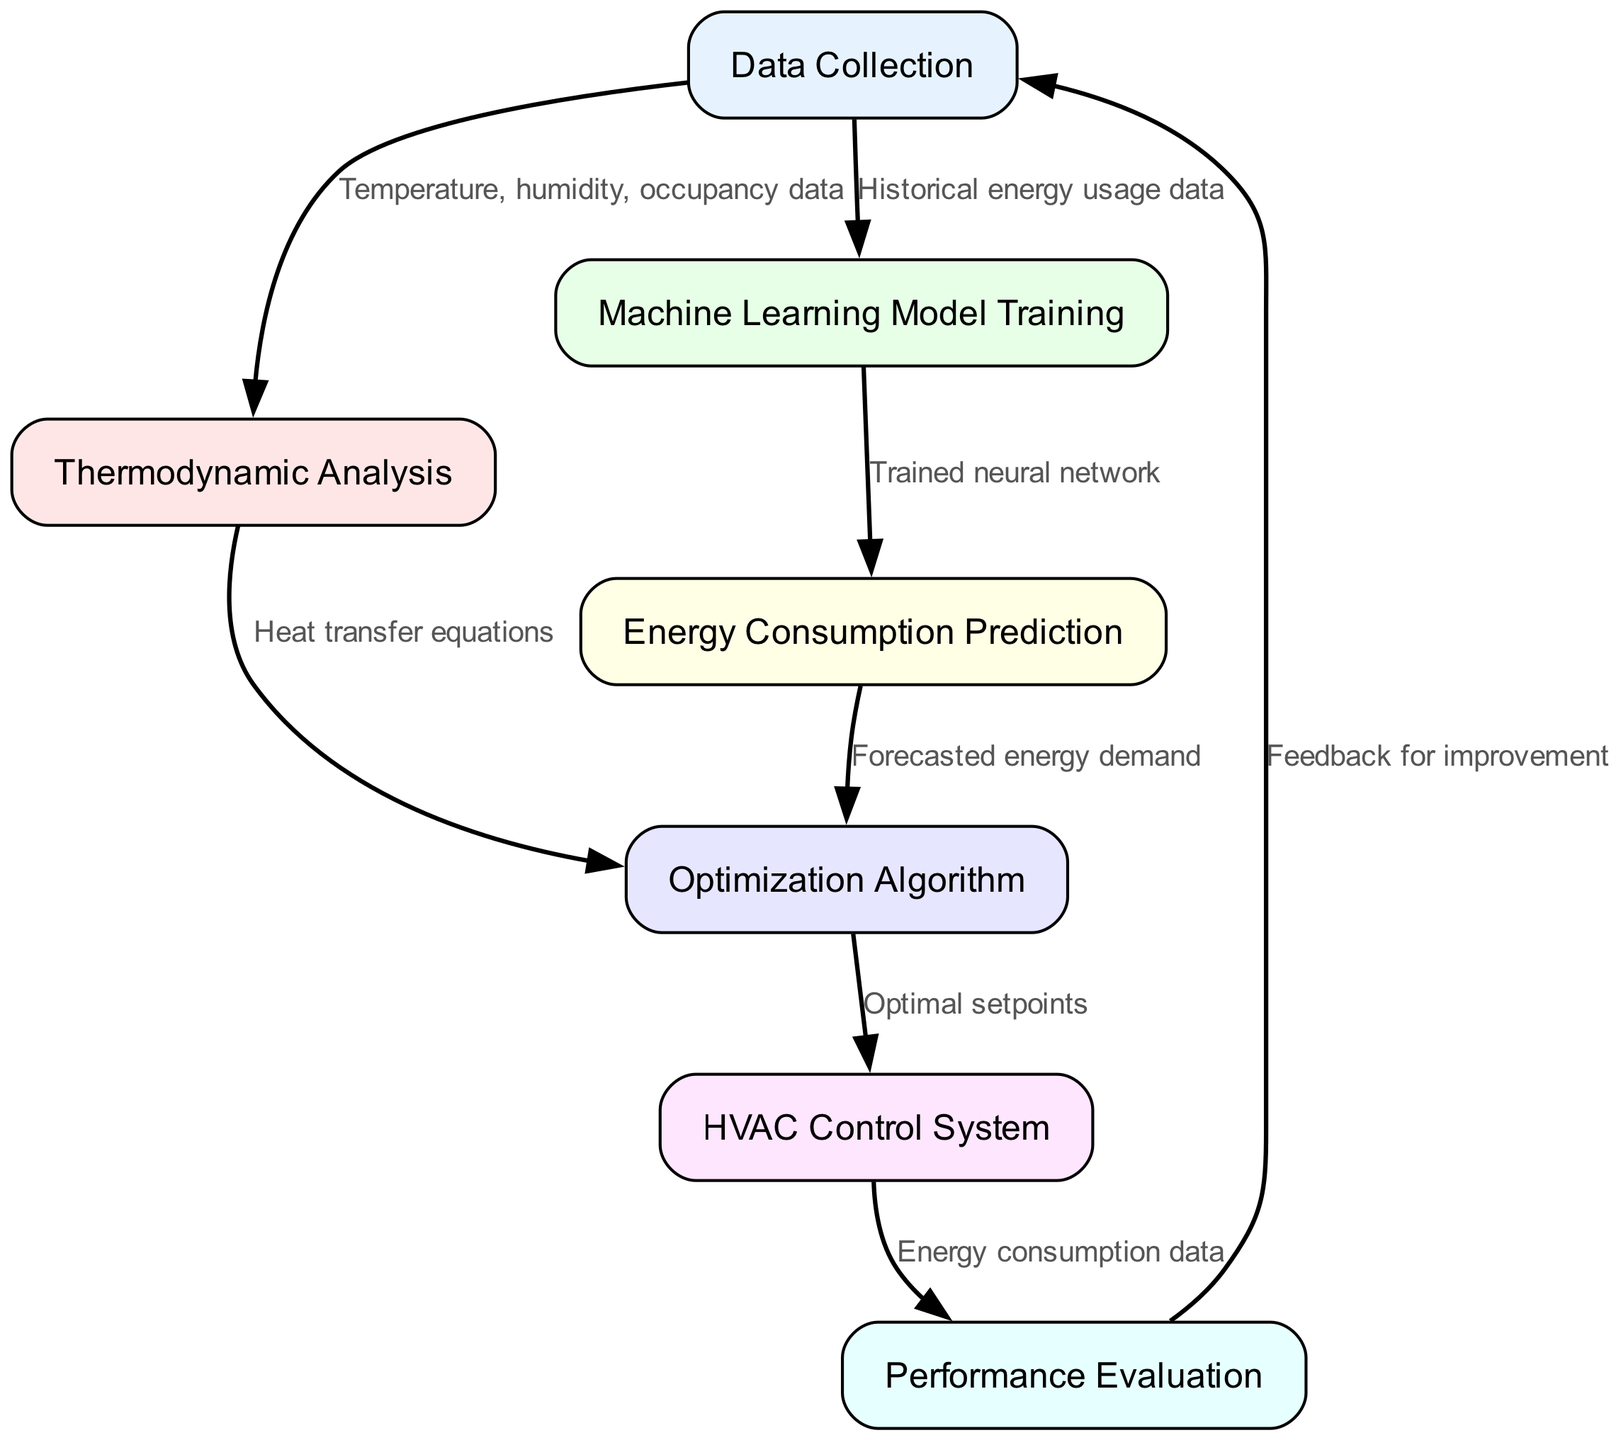What is the first step in the energy efficiency improvement procedure? According to the flow chart, the first step is "Data Collection." It is the starting point of the process that gathers necessary information about the building's environment and energy usage.
Answer: Data Collection How many nodes are in this flow chart? A count of the nodes in the diagram shows there are seven distinct steps outlined, each leading to another in the process of energy efficiency improvement.
Answer: Seven What type of data is used in the "Thermodynamic Analysis" step? The edge leading into "Thermodynamic Analysis" specifies that the type of data used in this step includes "Temperature, humidity, occupancy data." This data is crucial for analyzing the thermodynamic behaviors of the building environment.
Answer: Temperature, humidity, occupancy data Which step follows "Machine Learning Model Training"? The diagram indicates that "Energy Consumption Prediction" is the step that follows "Machine Learning Model Training," showing a clear sequential flow from training to predicting energy use.
Answer: Energy Consumption Prediction What is the output of the "Optimization Algorithm"? The edge coming out of "Optimization Algorithm" states that the output is "Optimal setpoints." This denotes the adjustments made based on the optimization process to enhance energy efficiency.
Answer: Optimal setpoints Which two steps are linked by the edge labeled "Forecasted energy demand"? The flow chart shows that "Energy Consumption Prediction" leads to "Optimization Algorithm," and this connection is specifically indicated by the phrase "Forecasted energy demand," illustrating a direct relationship in the process flow.
Answer: Energy Consumption Prediction and Optimization Algorithm What feedback is provided to the "Data Collection" step? The feedback indicated in the diagram is "Feedback for improvement." This step suggests that once performance evaluation is done, insights are channeled back to enhance the data collection process.
Answer: Feedback for improvement How does the "HVAC Control System" receive input? The arrow from "Optimization Algorithm" to "HVAC Control System" signifies the method of input, which consists of the "Optimal setpoints" that direct the controlling actions of the HVAC system for improved energy efficiency.
Answer: Optimal setpoints 